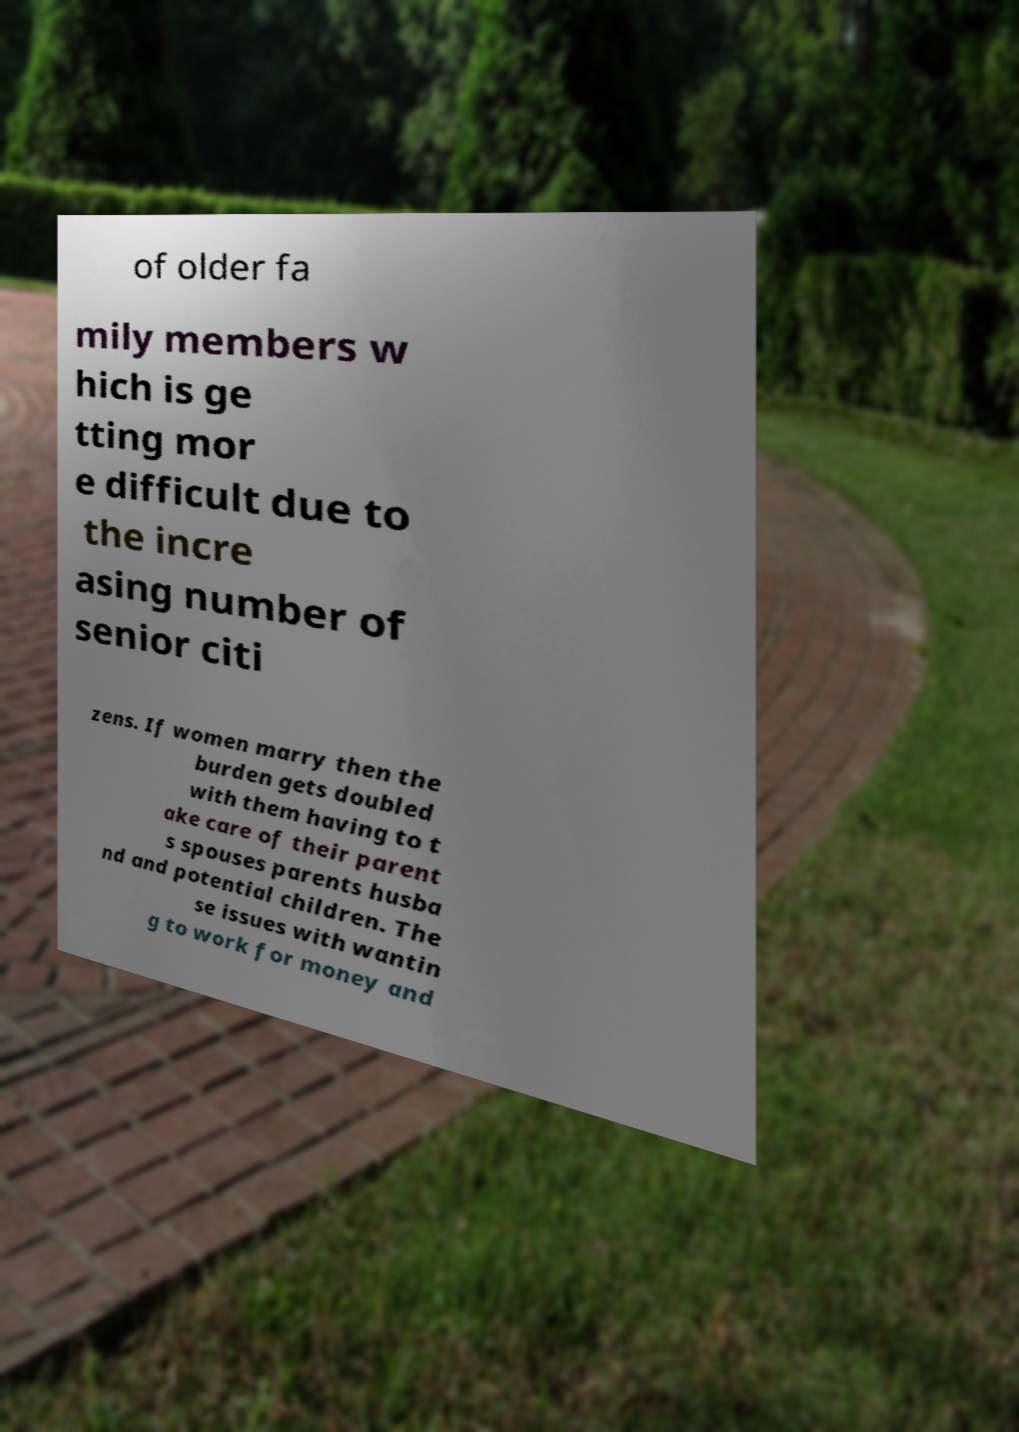Could you assist in decoding the text presented in this image and type it out clearly? of older fa mily members w hich is ge tting mor e difficult due to the incre asing number of senior citi zens. If women marry then the burden gets doubled with them having to t ake care of their parent s spouses parents husba nd and potential children. The se issues with wantin g to work for money and 